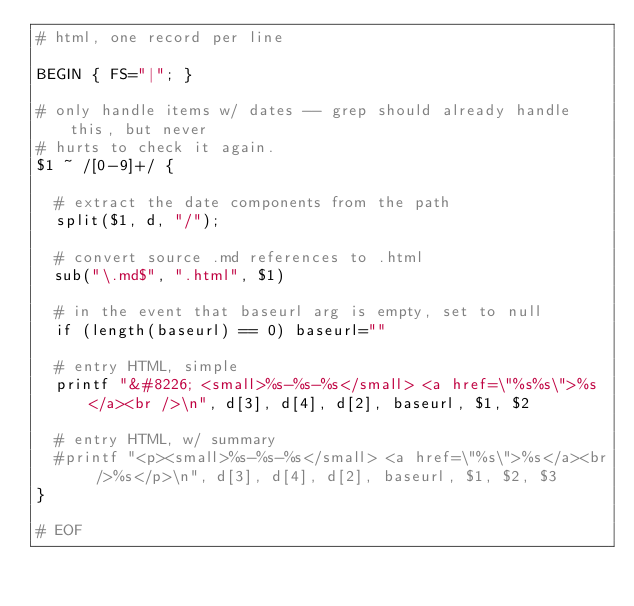Convert code to text. <code><loc_0><loc_0><loc_500><loc_500><_Awk_># html, one record per line

BEGIN { FS="|"; } 

# only handle items w/ dates -- grep should already handle this, but never
# hurts to check it again.
$1 ~ /[0-9]+/ { 

  # extract the date components from the path
  split($1, d, "/"); 

  # convert source .md references to .html
  sub("\.md$", ".html", $1)

  # in the event that baseurl arg is empty, set to null
  if (length(baseurl) == 0) baseurl=""

  # entry HTML, simple
  printf "&#8226; <small>%s-%s-%s</small> <a href=\"%s%s\">%s</a><br />\n", d[3], d[4], d[2], baseurl, $1, $2

  # entry HTML, w/ summary
  #printf "<p><small>%s-%s-%s</small> <a href=\"%s\">%s</a><br />%s</p>\n", d[3], d[4], d[2], baseurl, $1, $2, $3
}

# EOF
</code> 